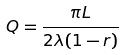<formula> <loc_0><loc_0><loc_500><loc_500>Q = \frac { \pi L } { 2 \lambda ( 1 - r ) }</formula> 